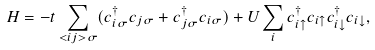<formula> <loc_0><loc_0><loc_500><loc_500>H = - t \sum _ { < i j > \sigma } ( c ^ { \dagger } _ { i \sigma } c _ { j \sigma } + c ^ { \dagger } _ { j \sigma } c _ { i \sigma } ) + U \sum _ { i } c ^ { \dagger } _ { i \uparrow } c _ { i \uparrow } c ^ { \dagger } _ { i \downarrow } c _ { i \downarrow } ,</formula> 